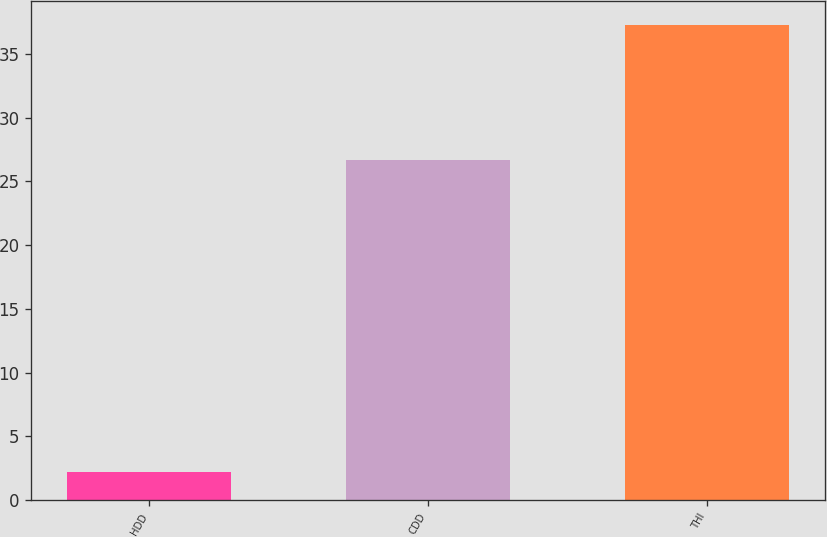<chart> <loc_0><loc_0><loc_500><loc_500><bar_chart><fcel>HDD<fcel>CDD<fcel>THI<nl><fcel>2.2<fcel>26.7<fcel>37.3<nl></chart> 